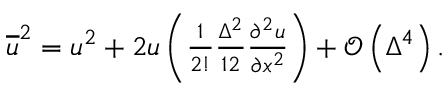<formula> <loc_0><loc_0><loc_500><loc_500>\begin{array} { r } { \overline { u } ^ { 2 } = u ^ { 2 } + 2 u \left ( \frac { 1 } { 2 ! } \frac { \Delta ^ { 2 } } { 1 2 } \frac { \partial ^ { 2 } u } { \partial x ^ { 2 } } \right ) + \mathcal { O } \left ( \Delta ^ { 4 } \right ) . } \end{array}</formula> 